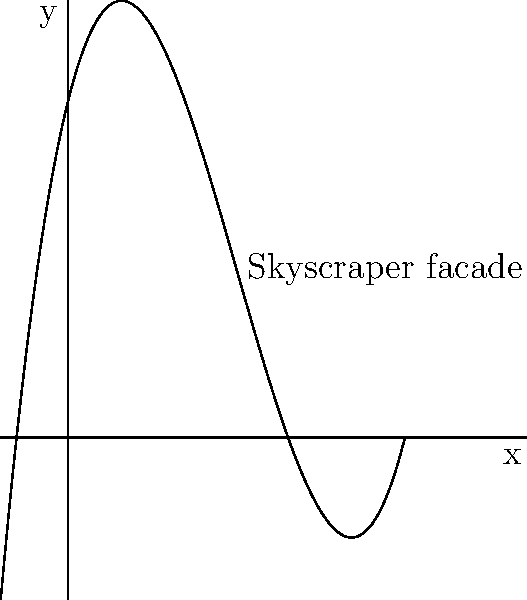A renowned architect is designing a skyscraper with a unique curved facade. The curvature can be modeled by the polynomial function $f(x) = 0.1x^3 - 1.5x^2 + 4x + 10$, where $x$ represents the horizontal distance from the base (in meters) and $f(x)$ represents the vertical distance from the ground (in meters). At what horizontal distance from the base does the facade reach its minimum height? To find the minimum height of the facade, we need to follow these steps:

1) The minimum point occurs where the derivative of the function equals zero. Let's find the derivative:

   $f'(x) = 0.3x^2 - 3x + 4$

2) Set the derivative equal to zero and solve for x:

   $0.3x^2 - 3x + 4 = 0$

3) This is a quadratic equation. We can solve it using the quadratic formula:
   $x = \frac{-b \pm \sqrt{b^2 - 4ac}}{2a}$

   Where $a = 0.3$, $b = -3$, and $c = 4$

4) Plugging in these values:

   $x = \frac{3 \pm \sqrt{9 - 4.8}}{0.6} = \frac{3 \pm \sqrt{4.2}}{0.6}$

5) Simplifying:

   $x = \frac{3 \pm 2.05}{0.6}$

6) This gives us two solutions:

   $x_1 = \frac{3 + 2.05}{0.6} \approx 8.42$ meters
   $x_2 = \frac{3 - 2.05}{0.6} \approx 1.58$ meters

7) The smaller value, 1.58 meters, corresponds to the minimum point of the facade.
Answer: 1.58 meters 